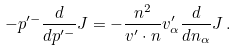Convert formula to latex. <formula><loc_0><loc_0><loc_500><loc_500>- p ^ { \prime - } \frac { d } { d p ^ { \prime - } } J = - \frac { n ^ { 2 } } { v ^ { \prime } \cdot n } v ^ { \prime } _ { \alpha } \frac { d } { d n _ { \alpha } } J \, .</formula> 